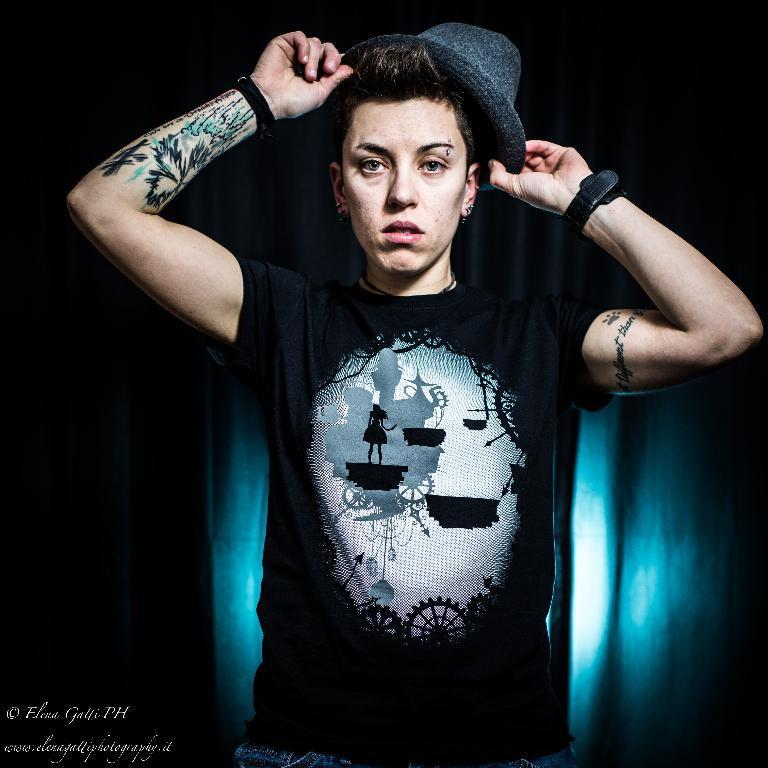Can you describe this image briefly? In this picture we can see a person, he is holding a cap, at the back of him we can see a curtain and in the background we can see it is dark, in the bottom left we can see some text on it. 